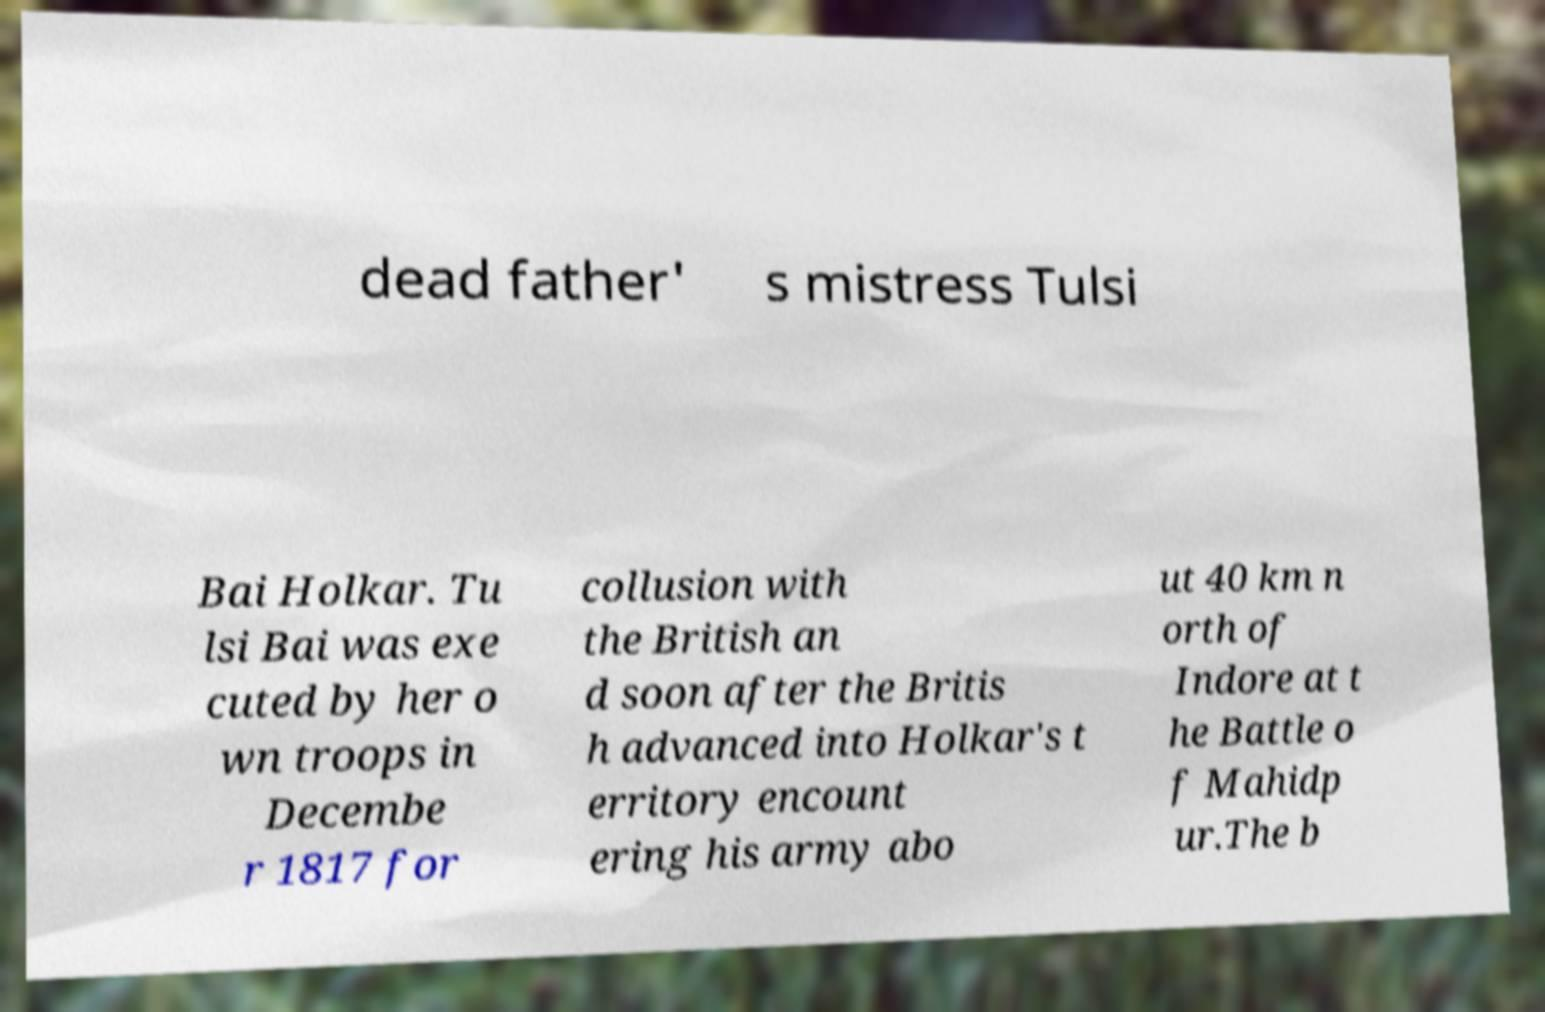Please read and relay the text visible in this image. What does it say? dead father' s mistress Tulsi Bai Holkar. Tu lsi Bai was exe cuted by her o wn troops in Decembe r 1817 for collusion with the British an d soon after the Britis h advanced into Holkar's t erritory encount ering his army abo ut 40 km n orth of Indore at t he Battle o f Mahidp ur.The b 